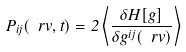<formula> <loc_0><loc_0><loc_500><loc_500>P _ { i j } ( \ r v , t ) = 2 \left \langle \frac { \delta H [ { g } ] } { \delta g ^ { i j } ( \ r v ) } \right \rangle</formula> 